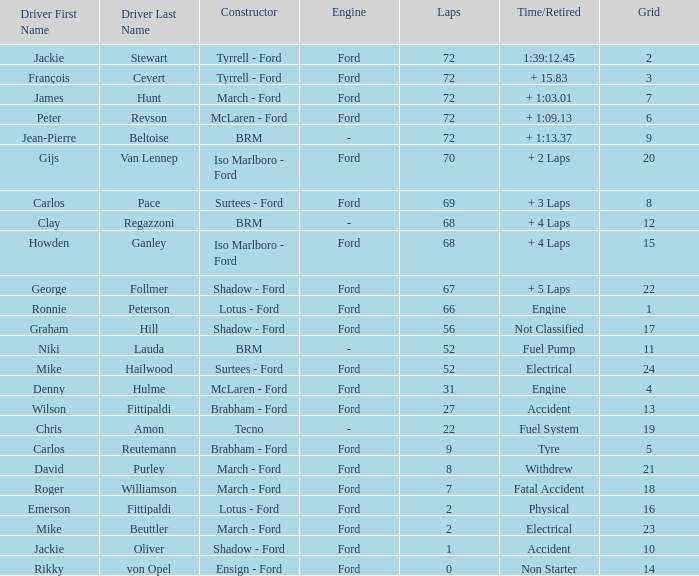Parse the table in full. {'header': ['Driver First Name', 'Driver Last Name', 'Constructor', 'Engine', 'Laps', 'Time/Retired', 'Grid'], 'rows': [['Jackie', 'Stewart', 'Tyrrell - Ford', 'Ford', '72', '1:39:12.45', '2'], ['François', 'Cevert', 'Tyrrell - Ford', 'Ford', '72', '+ 15.83', '3'], ['James', 'Hunt', 'March - Ford', 'Ford', '72', '+ 1:03.01', '7'], ['Peter', 'Revson', 'McLaren - Ford', 'Ford', '72', '+ 1:09.13', '6'], ['Jean-Pierre', 'Beltoise', 'BRM', '-', '72', '+ 1:13.37', '9'], ['Gijs', 'Van Lennep', 'Iso Marlboro - Ford', 'Ford', '70', '+ 2 Laps', '20'], ['Carlos', 'Pace', 'Surtees - Ford', 'Ford', '69', '+ 3 Laps', '8'], ['Clay', 'Regazzoni', 'BRM', '-', '68', '+ 4 Laps', '12'], ['Howden', 'Ganley', 'Iso Marlboro - Ford', 'Ford', '68', '+ 4 Laps', '15'], ['George', 'Follmer', 'Shadow - Ford', 'Ford', '67', '+ 5 Laps', '22'], ['Ronnie', 'Peterson', 'Lotus - Ford', 'Ford', '66', 'Engine', '1'], ['Graham', 'Hill', 'Shadow - Ford', 'Ford', '56', 'Not Classified', '17'], ['Niki', 'Lauda', 'BRM', '-', '52', 'Fuel Pump', '11'], ['Mike', 'Hailwood', 'Surtees - Ford', 'Ford', '52', 'Electrical', '24'], ['Denny', 'Hulme', 'McLaren - Ford', 'Ford', '31', 'Engine', '4'], ['Wilson', 'Fittipaldi', 'Brabham - Ford', 'Ford', '27', 'Accident', '13'], ['Chris', 'Amon', 'Tecno', '-', '22', 'Fuel System', '19'], ['Carlos', 'Reutemann', 'Brabham - Ford', 'Ford', '9', 'Tyre', '5'], ['David', 'Purley', 'March - Ford', 'Ford', '8', 'Withdrew', '21'], ['Roger', 'Williamson', 'March - Ford', 'Ford', '7', 'Fatal Accident', '18'], ['Emerson', 'Fittipaldi', 'Lotus - Ford', 'Ford', '2', 'Physical', '16'], ['Mike', 'Beuttler', 'March - Ford', 'Ford', '2', 'Electrical', '23'], ['Jackie', 'Oliver', 'Shadow - Ford', 'Ford', '1', 'Accident', '10'], ['Rikky', 'von Opel', 'Ensign - Ford', 'Ford', '0', 'Non Starter', '14']]} What is the top lap that had a tyre time? 9.0. 